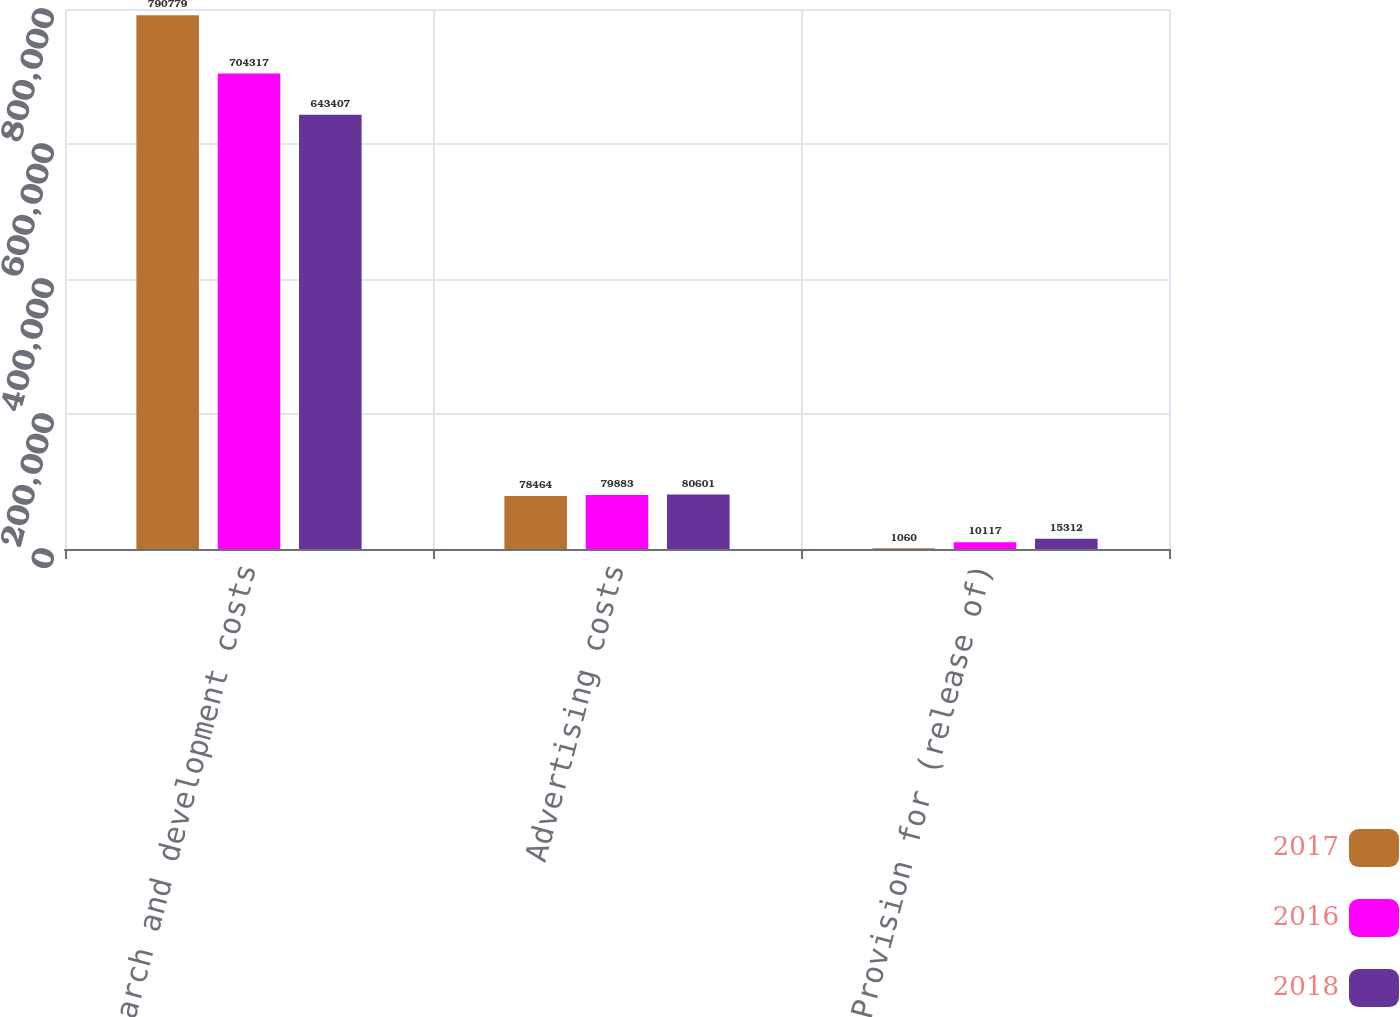<chart> <loc_0><loc_0><loc_500><loc_500><stacked_bar_chart><ecel><fcel>Research and development costs<fcel>Advertising costs<fcel>Provision for (release of)<nl><fcel>2017<fcel>790779<fcel>78464<fcel>1060<nl><fcel>2016<fcel>704317<fcel>79883<fcel>10117<nl><fcel>2018<fcel>643407<fcel>80601<fcel>15312<nl></chart> 